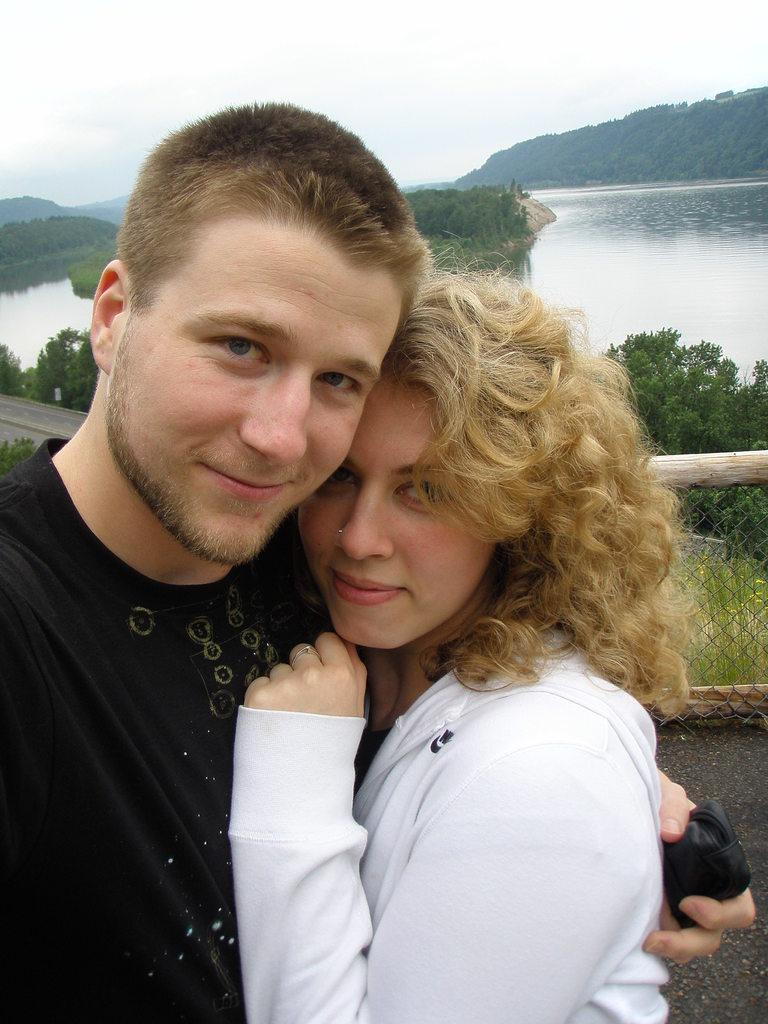Who is present in the image? There is a man and a woman in the image. What are the man and woman doing in the image? The man and woman are standing and smiling. What can be seen in the background of the image? There is a fence, water flowing, trees, and a hill in the image. What type of thread is being used to create the houses in the image? There are no houses present in the image, so there is no thread being used to create them. 